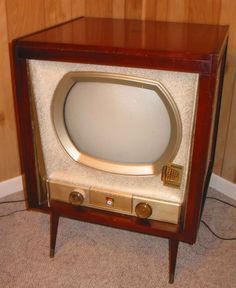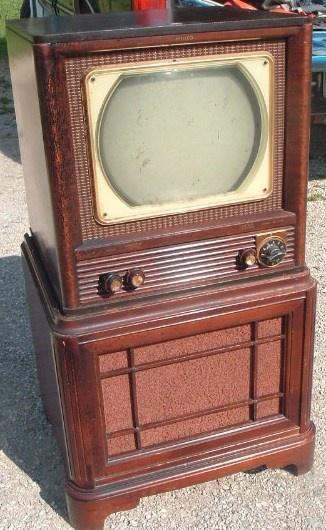The first image is the image on the left, the second image is the image on the right. Analyze the images presented: Is the assertion "Each of two televisions is contained in the upper section of a wooden cabinet with a speaker area under the television, and two visible control knobs." valid? Answer yes or no. No. The first image is the image on the left, the second image is the image on the right. Assess this claim about the two images: "An image shows an old-fashioned wood-cased TV set with an oblong screen, elevated with slender tapered wood legs.". Correct or not? Answer yes or no. Yes. 